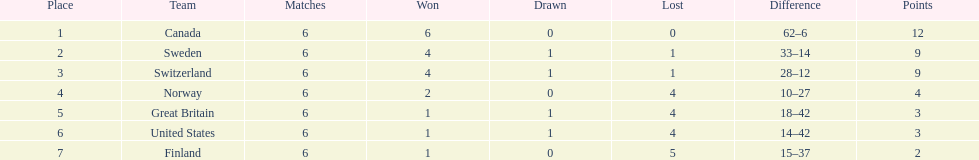How many teams won at least 4 matches? 3. 